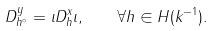Convert formula to latex. <formula><loc_0><loc_0><loc_500><loc_500>D _ { h ^ { \circ } } ^ { y } = \iota D _ { h } ^ { x } \iota , \quad \forall h \in H ( k ^ { - 1 } ) .</formula> 